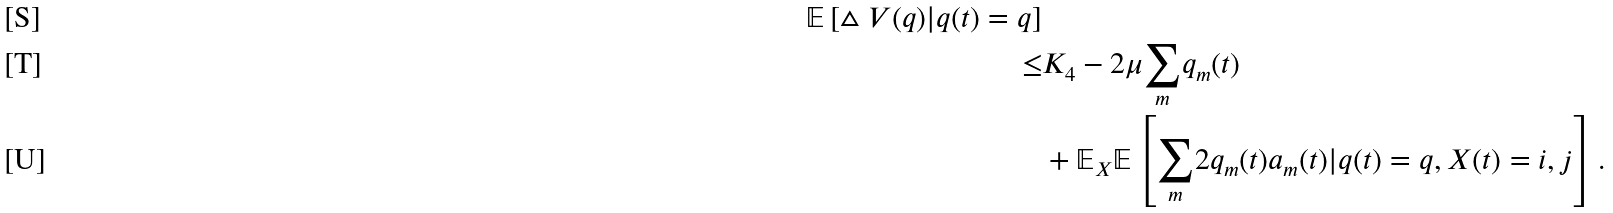<formula> <loc_0><loc_0><loc_500><loc_500>{ \mathbb { E } \left [ \vartriangle V ( q ) | q ( t ) = q \right ] } \\ \leq & K _ { 4 } - 2 \mu \underset { m } { \sum } q _ { m } ( t ) \\ & + \mathbb { E } _ { X } \mathbb { E } \left [ \underset { m } { \sum } 2 q _ { m } ( t ) a _ { m } ( t ) | q ( t ) = q , X ( t ) = i , j \right ] .</formula> 